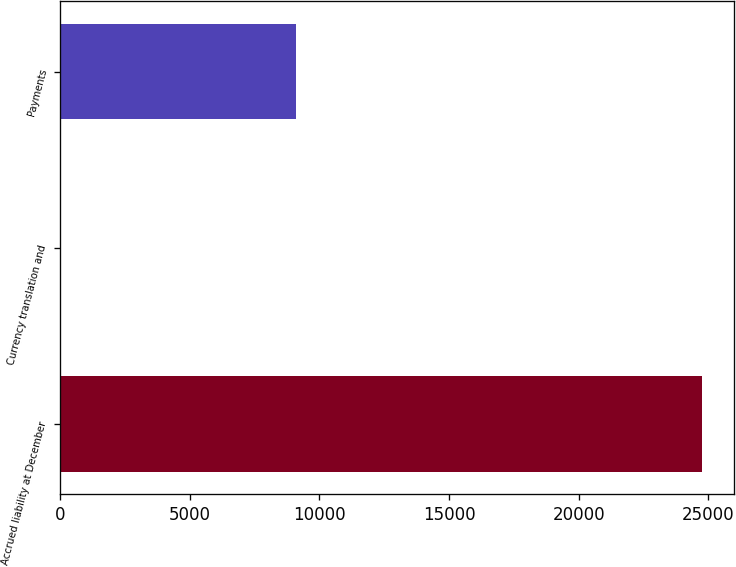Convert chart to OTSL. <chart><loc_0><loc_0><loc_500><loc_500><bar_chart><fcel>Accrued liability at December<fcel>Currency translation and<fcel>Payments<nl><fcel>24773<fcel>51<fcel>9113<nl></chart> 